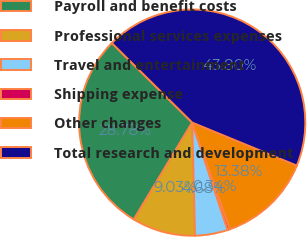Convert chart to OTSL. <chart><loc_0><loc_0><loc_500><loc_500><pie_chart><fcel>Payroll and benefit costs<fcel>Professional services expenses<fcel>Travel and entertainment<fcel>Shipping expense<fcel>Other changes<fcel>Total research and development<nl><fcel>28.78%<fcel>9.03%<fcel>4.68%<fcel>0.34%<fcel>13.38%<fcel>43.8%<nl></chart> 